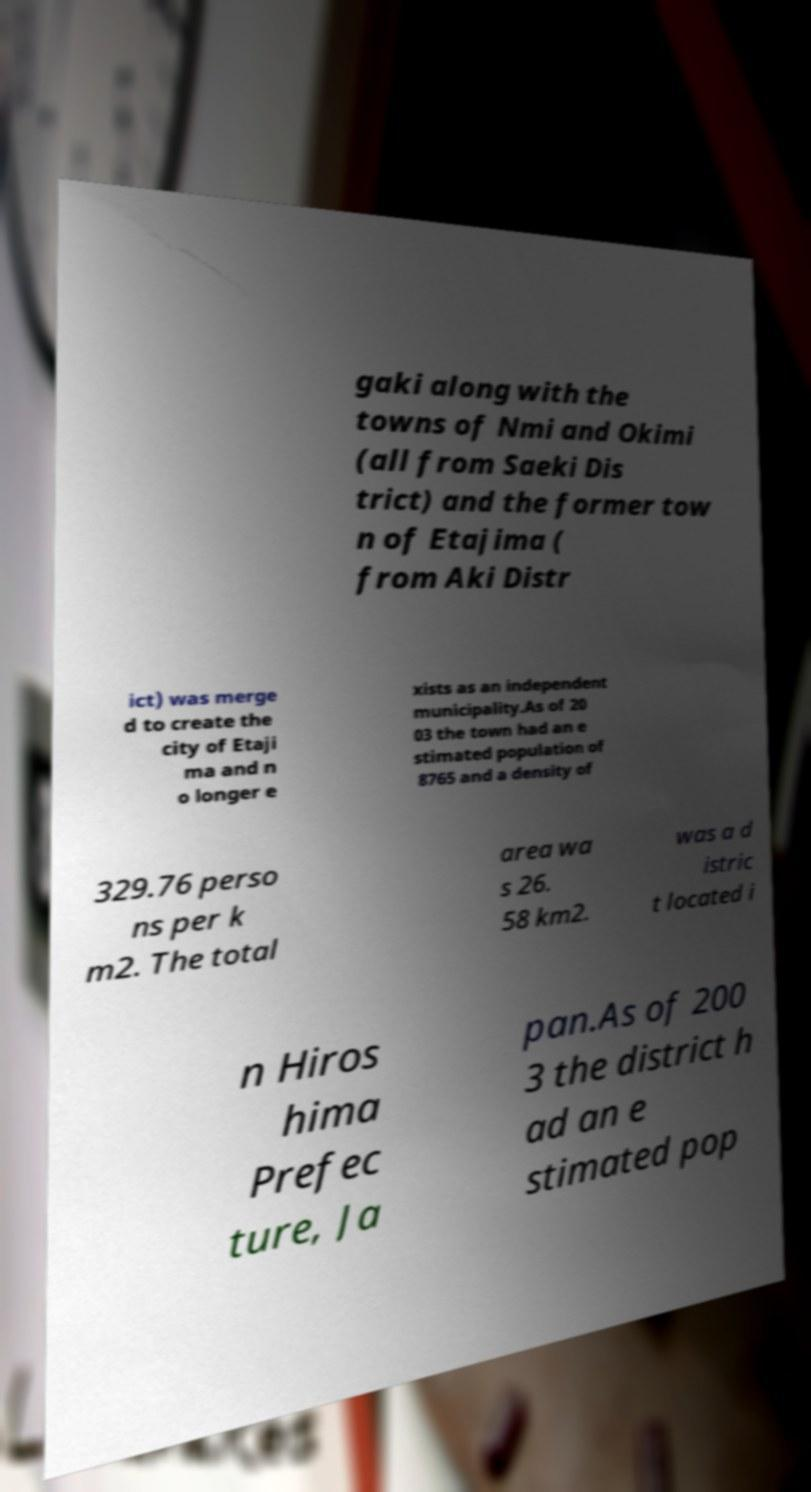Could you assist in decoding the text presented in this image and type it out clearly? gaki along with the towns of Nmi and Okimi (all from Saeki Dis trict) and the former tow n of Etajima ( from Aki Distr ict) was merge d to create the city of Etaji ma and n o longer e xists as an independent municipality.As of 20 03 the town had an e stimated population of 8765 and a density of 329.76 perso ns per k m2. The total area wa s 26. 58 km2. was a d istric t located i n Hiros hima Prefec ture, Ja pan.As of 200 3 the district h ad an e stimated pop 